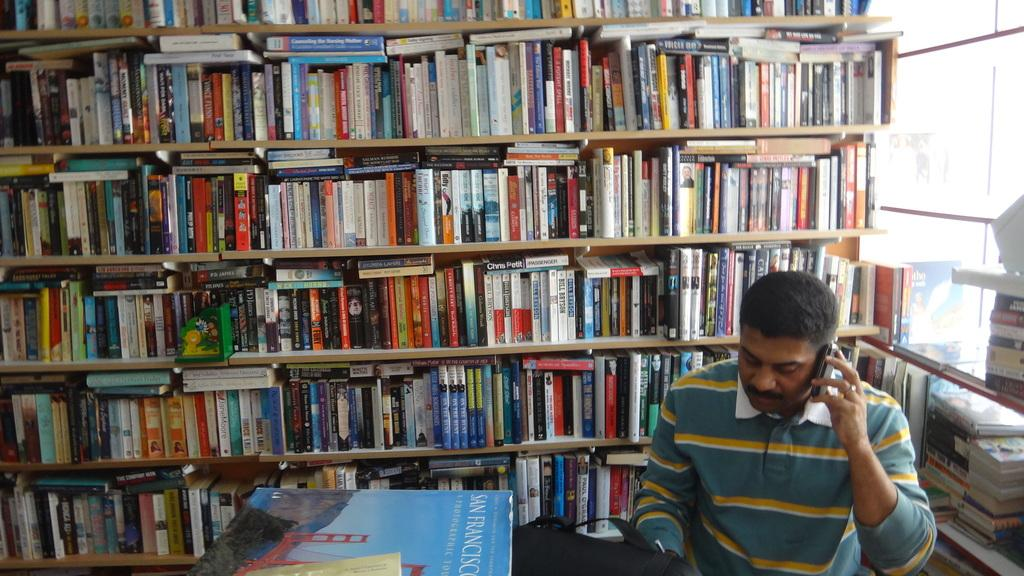<image>
Write a terse but informative summary of the picture. A man talks on his cell phone with a book about San Francisco on the table. 